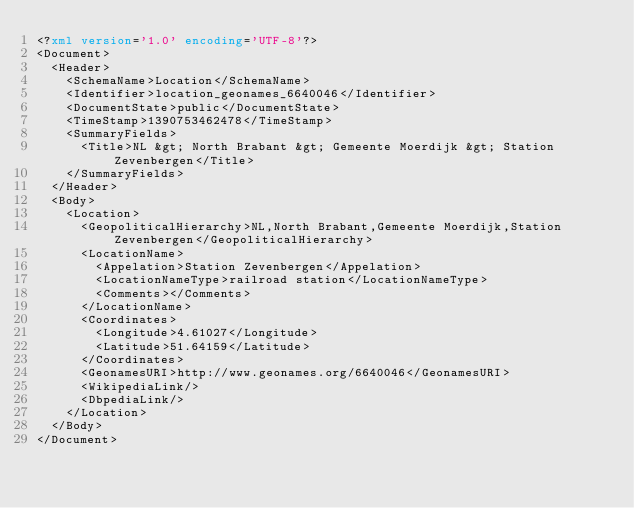Convert code to text. <code><loc_0><loc_0><loc_500><loc_500><_XML_><?xml version='1.0' encoding='UTF-8'?>
<Document>
  <Header>
    <SchemaName>Location</SchemaName>
    <Identifier>location_geonames_6640046</Identifier>
    <DocumentState>public</DocumentState>
    <TimeStamp>1390753462478</TimeStamp>
    <SummaryFields>
      <Title>NL &gt; North Brabant &gt; Gemeente Moerdijk &gt; Station Zevenbergen</Title>
    </SummaryFields>
  </Header>
  <Body>
    <Location>
      <GeopoliticalHierarchy>NL,North Brabant,Gemeente Moerdijk,Station Zevenbergen</GeopoliticalHierarchy>
      <LocationName>
        <Appelation>Station Zevenbergen</Appelation>
        <LocationNameType>railroad station</LocationNameType>
        <Comments></Comments>
      </LocationName>
      <Coordinates>
        <Longitude>4.61027</Longitude>
        <Latitude>51.64159</Latitude>
      </Coordinates>
      <GeonamesURI>http://www.geonames.org/6640046</GeonamesURI>
      <WikipediaLink/>
      <DbpediaLink/>
    </Location>
  </Body>
</Document>
</code> 